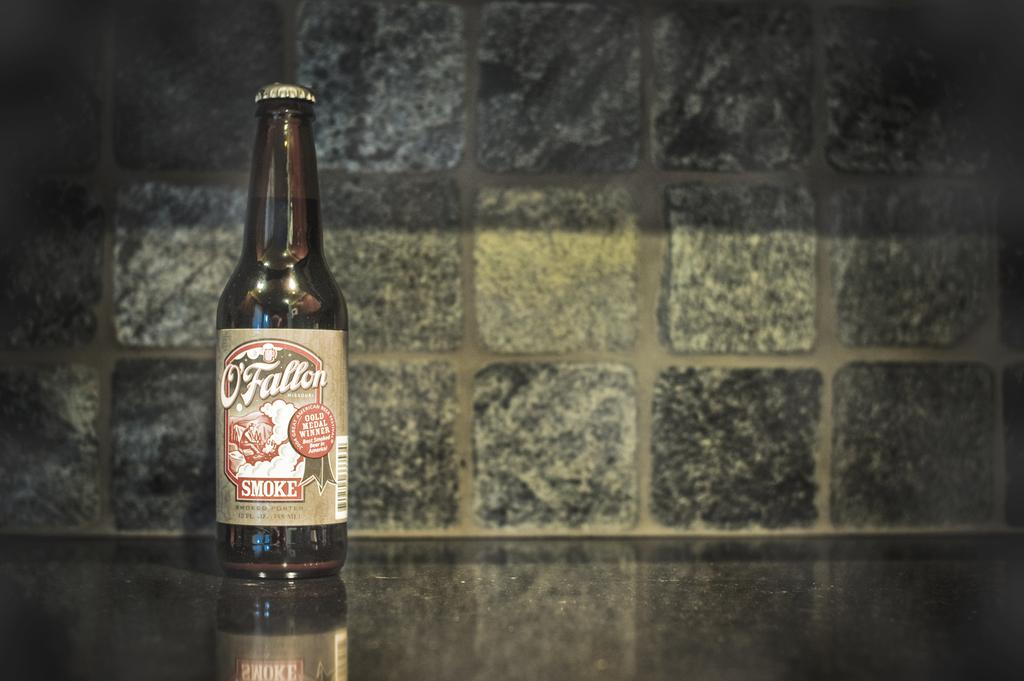<image>
Give a short and clear explanation of the subsequent image. A bottle O'Fallon sits on the counter with tiles in the background 